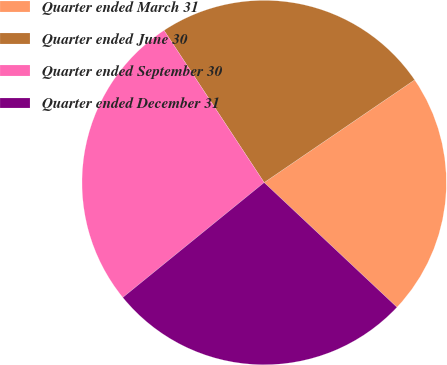Convert chart to OTSL. <chart><loc_0><loc_0><loc_500><loc_500><pie_chart><fcel>Quarter ended March 31<fcel>Quarter ended June 30<fcel>Quarter ended September 30<fcel>Quarter ended December 31<nl><fcel>21.53%<fcel>24.73%<fcel>26.6%<fcel>27.13%<nl></chart> 